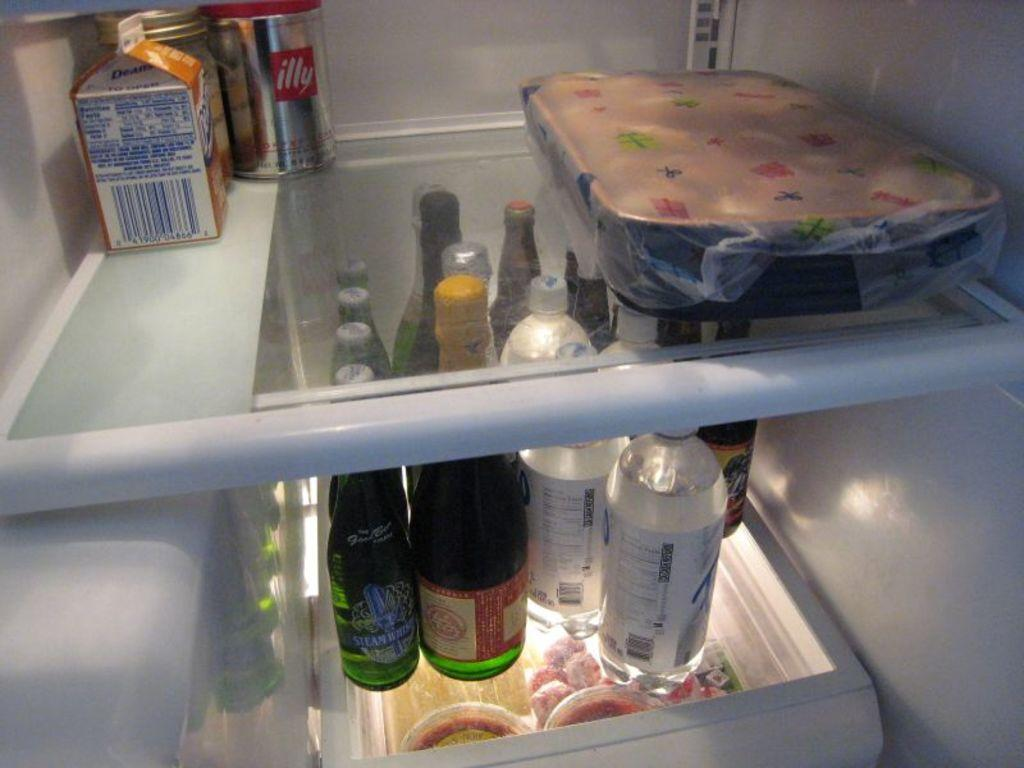<image>
Relay a brief, clear account of the picture shown. The inside of a fridge with a "illy" aluminum can on the top shelf. 